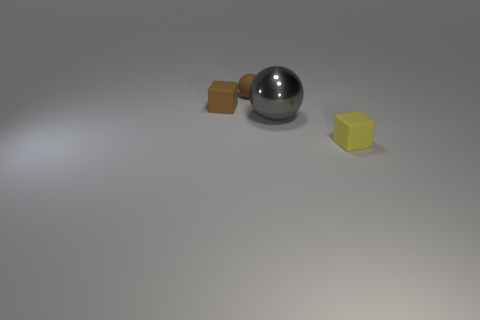There is a tiny thing that is the same color as the small rubber sphere; what shape is it?
Make the answer very short. Cube. Do the brown ball and the ball that is in front of the rubber sphere have the same size?
Ensure brevity in your answer.  No. Are there any other things that are the same material as the gray thing?
Make the answer very short. No. There is a matte cube that is behind the yellow matte object; does it have the same size as the object that is to the right of the gray shiny object?
Keep it short and to the point. Yes. What number of tiny objects are either matte balls or brown matte cubes?
Offer a very short reply. 2. What number of objects are both to the left of the yellow block and in front of the tiny brown rubber block?
Provide a short and direct response. 1. Is the material of the small yellow cube the same as the tiny block that is behind the large shiny object?
Keep it short and to the point. Yes. What number of green objects are small rubber blocks or small cylinders?
Your answer should be very brief. 0. Is there a rubber cube of the same size as the yellow object?
Make the answer very short. Yes. There is a tiny cube that is behind the matte object to the right of the ball behind the small brown cube; what is it made of?
Ensure brevity in your answer.  Rubber. 